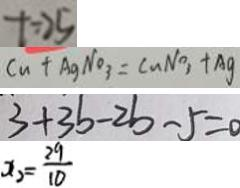<formula> <loc_0><loc_0><loc_500><loc_500>t = 2 5 
 C u + A g N O _ { 3 } = C u N O _ { 3 } + A g 
 3 + 3 b - 2 b - 5 = 0 
 x _ { 2 } = \frac { 2 9 } { 1 0 }</formula> 